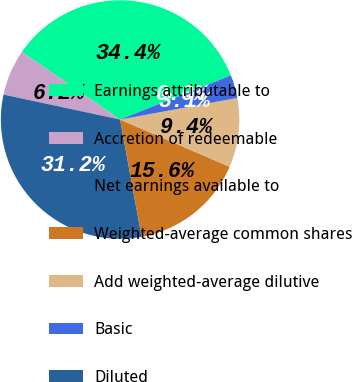Convert chart to OTSL. <chart><loc_0><loc_0><loc_500><loc_500><pie_chart><fcel>Earnings attributable to<fcel>Accretion of redeemable<fcel>Net earnings available to<fcel>Weighted-average common shares<fcel>Add weighted-average dilutive<fcel>Basic<fcel>Diluted<nl><fcel>34.37%<fcel>6.25%<fcel>31.25%<fcel>15.63%<fcel>9.38%<fcel>3.13%<fcel>0.0%<nl></chart> 